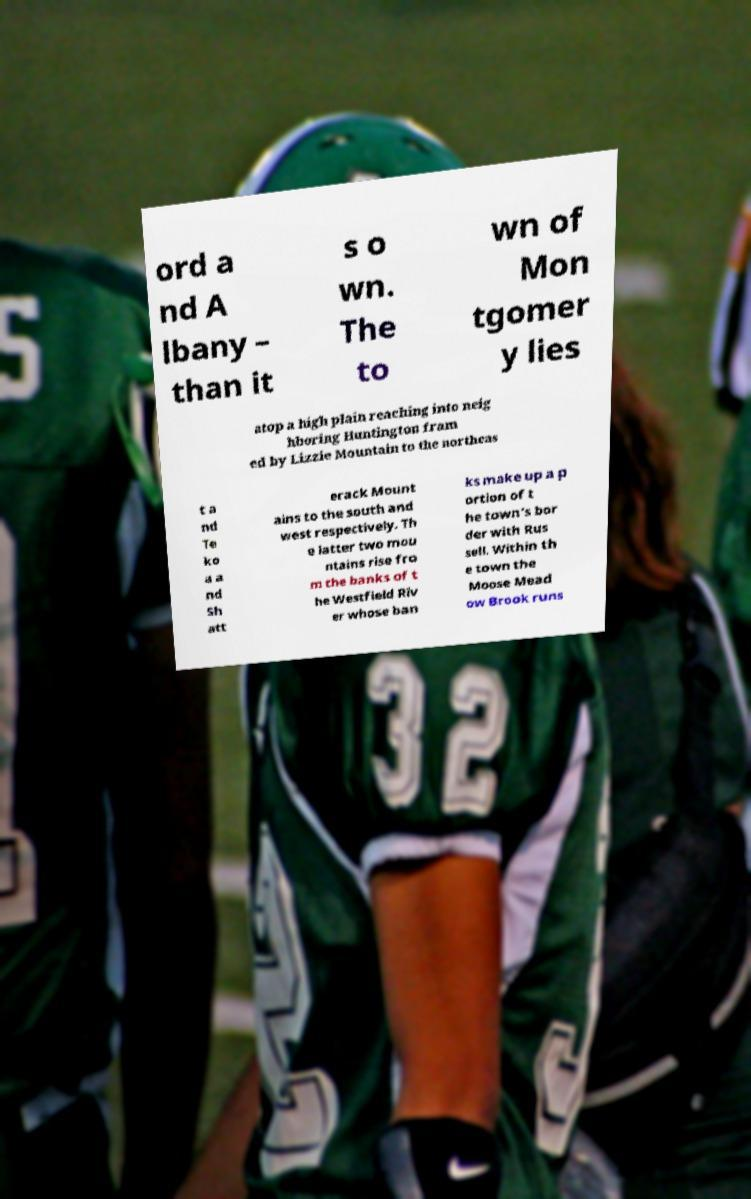Can you accurately transcribe the text from the provided image for me? ord a nd A lbany – than it s o wn. The to wn of Mon tgomer y lies atop a high plain reaching into neig hboring Huntington fram ed by Lizzie Mountain to the northeas t a nd Te ko a a nd Sh att erack Mount ains to the south and west respectively. Th e latter two mou ntains rise fro m the banks of t he Westfield Riv er whose ban ks make up a p ortion of t he town's bor der with Rus sell. Within th e town the Moose Mead ow Brook runs 